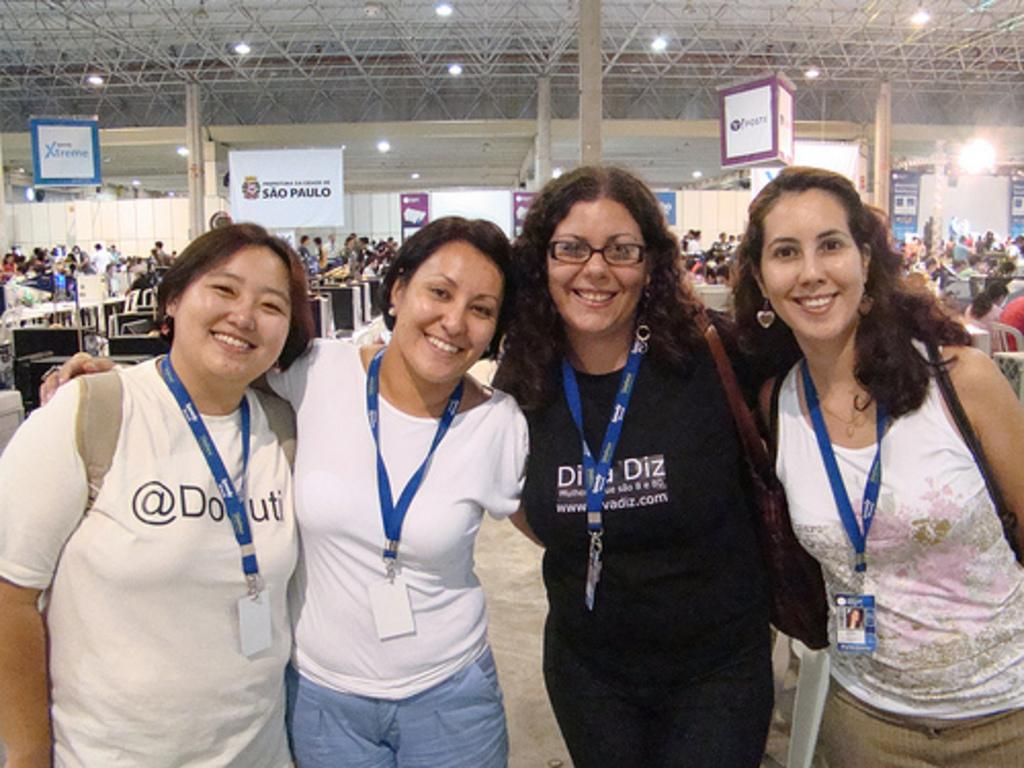<image>
Summarize the visual content of the image. Xtreme is written in blue on a banner hanging near the ceiling. 